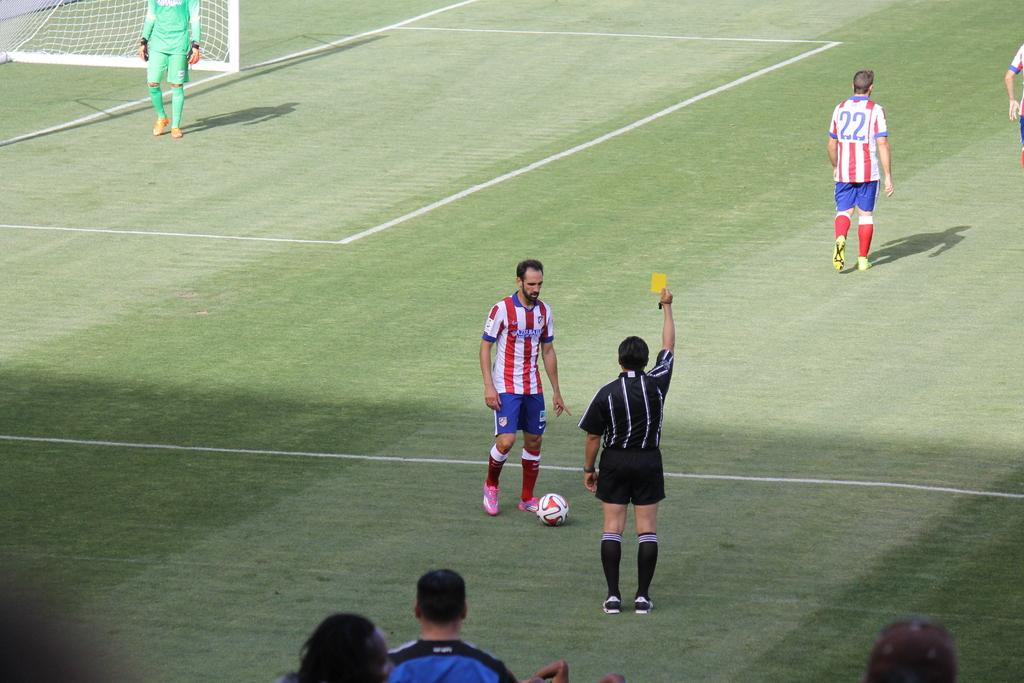What is the main setting of the image? There is a playground in the image. What are the people in the image wearing? The people in the image are wearing sports attire. What object is on the ground in the image? There is a football on the ground in the image. What structure is visible in the image? There is a net visible in the image. Where is the kettle located in the image? There is no kettle present in the image. What type of slip is being worn by the people in the image? The people in the image are wearing sports attire, not slippers. 